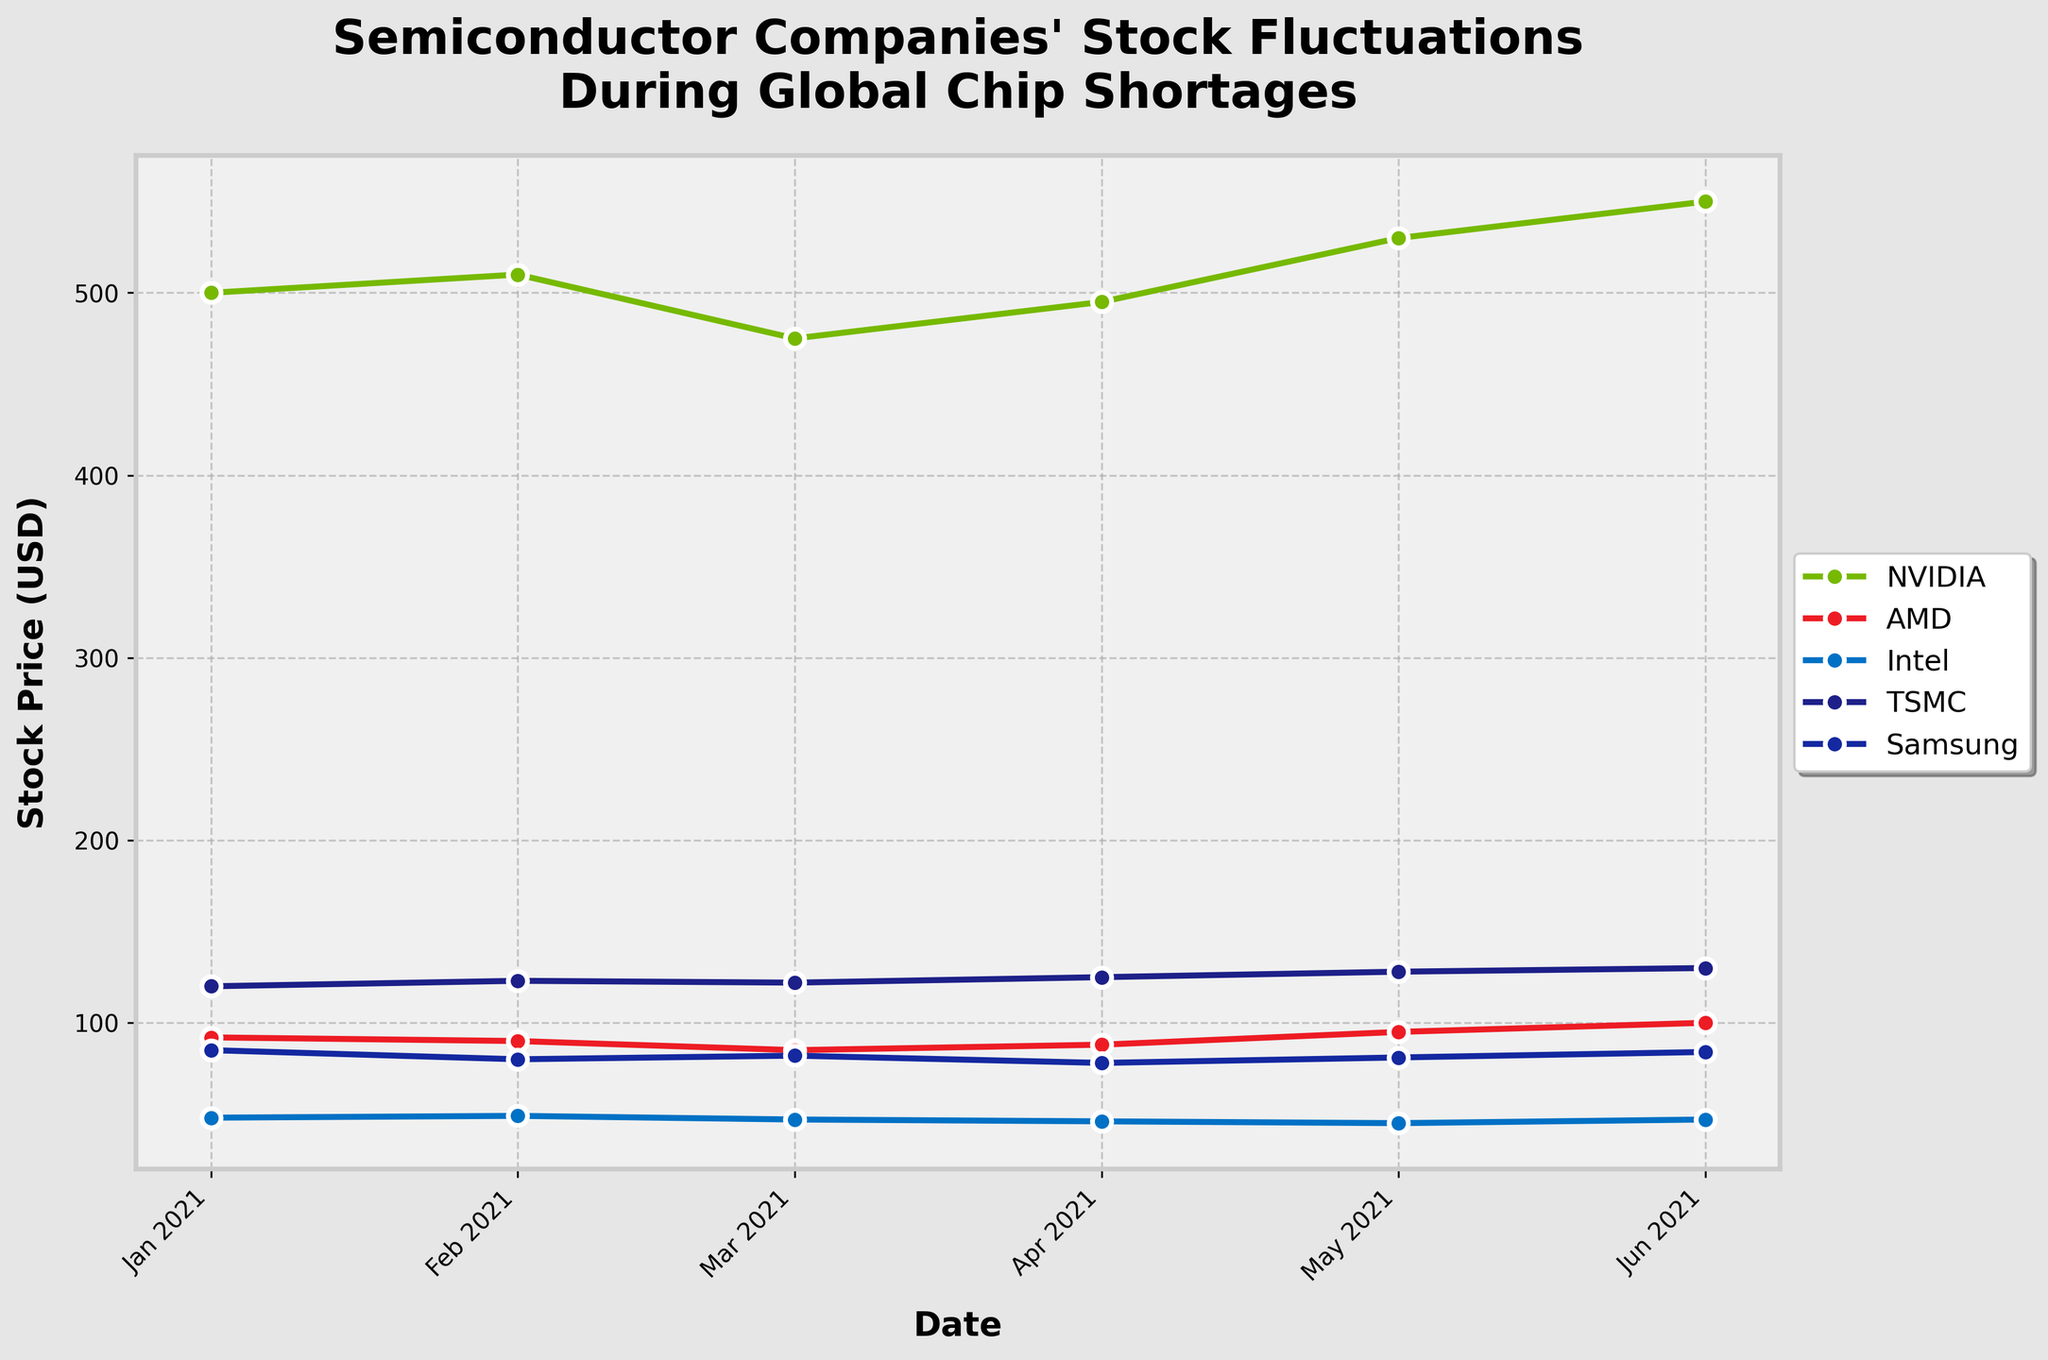What does the title of the plot indicate? The title of the plot appears at the top and it specifies that the figure shows stock price fluctuations of semiconductor companies during global chip shortages.
Answer: Semiconductor Companies' Stock Fluctuations During Global Chip Shortages What time period does the x-axis represent? The x-axis represents the date range from January 2021 to June 2021, displaying monthly intervals.
Answer: January 2021 to June 2021 Which company had the lowest stock price in March 2021? The plot shows different stock prices for each company at different dates. For March 2021, the lowest stock price can be found by looking at the data points for each company. Samsung had the lowest at $82.
Answer: Samsung Which companies showed an increase in stock price from May 2021 to June 2021? To determine which companies showed an increase, look at the stock prices for each company in May 2021 and compare them to June 2021. NVIDIA (530 to 550), AMD (95 to 100), TSMC (128 to 130), and Samsung (81 to 84) showed an increase. Intel remained the same (45 to 47).
Answer: NVIDIA, AMD, TSMC, Samsung Which company exhibited the most fluctuating stock prices during the period? To determine the most fluctuating stock prices, observe the variation in the plotted lines for each company. NVIDIA's stock prices showed larger fluctuations compared to others.
Answer: NVIDIA How did the stock prices of AMD and NVIDIA compare in April 2021? By looking at the April 2021 data points for both AMD and NVIDIA, NVIDIA's stock price was $495, and AMD's stock price was $88. Comparing these values, NVIDIA's stock price was higher.
Answer: NVIDIA had a higher stock price What is the average stock price of Intel over the six-month period? To find the average, sum up the stock prices of Intel from January to June (48, 49, 47, 46, 45, 47) and divide by 6. (48 + 49 + 47 + 46 + 45 + 47) = 282 / 6 = 47.
Answer: 47 Which companies had a stock price over $500 at any given time? Review the stock prices over the period to see if at any point they are above $500. Both NVIDIA and TSMC had prices above $500. NVIDIA's stock price crossed $500 multiple times, and TSMC always had prices above $500.
Answer: NVIDIA, TSMC What was the trend for Samsung's stock price from January to June 2021? To determine the trend, observe the progression of Samsung's data points from January to June. Samsung's stock price started at $85, dropped to $80 by February, fluctuated, and ended at $84 in June, showing an overall slight decrease and then recovering near the starting price.
Answer: Slight decrease, then recovery Which company showed the most consistent increase in stock price during the timeframe? To find the most consistent increase, look at the trend lines for all companies. TSMC shows a consistently increasing trend from $120 in January to $130 in June.
Answer: TSMC 